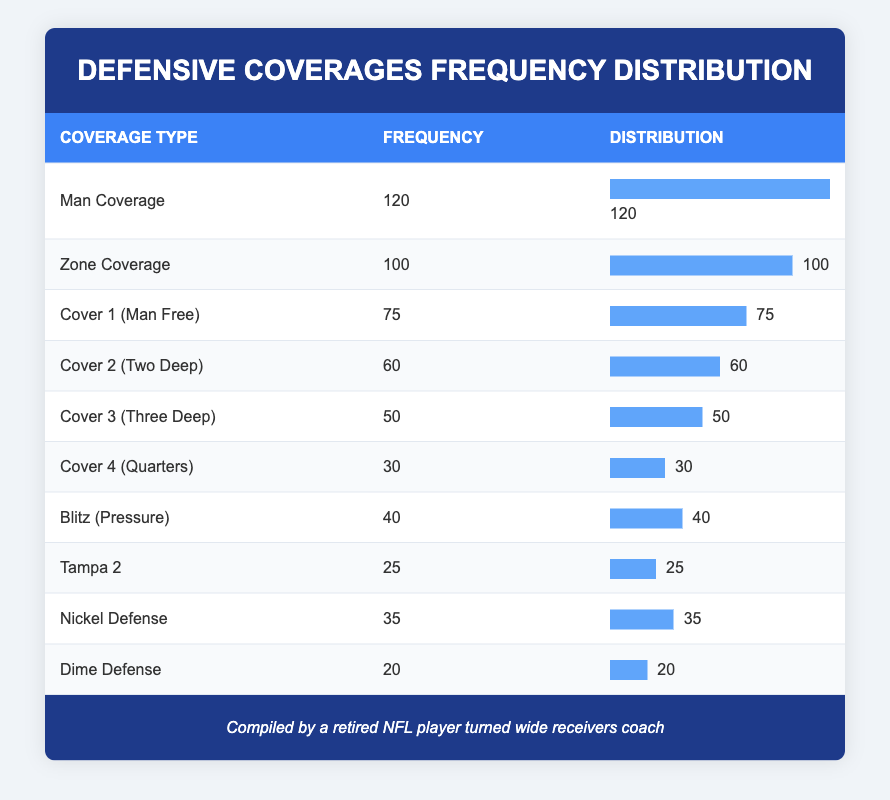What is the frequency of Man Coverage? Man Coverage has a frequency of 120 as stated in the table under the Frequency column.
Answer: 120 What defensive coverage type is faced the least by wide receivers? By looking at the Frequency column, Dime Defense has the lowest frequency at 20.
Answer: Dime Defense What is the total frequency of all defensive coverages combined? Adding up all the frequencies: 120 + 100 + 75 + 60 + 50 + 30 + 40 + 25 + 35 + 20 = 530.
Answer: 530 Is the frequency of Zone Coverage greater than that of Blitz (Pressure)? The frequency for Zone Coverage is 100 and for Blitz (Pressure) is 40. Since 100 is greater than 40, the statement is true.
Answer: Yes What is the average frequency of the top three defensive coverages? The top three defensive coverages by frequency are Man Coverage (120), Zone Coverage (100), and Cover 1 (75). The average is calculated as (120 + 100 + 75) / 3 = 295 / 3 = 98.33.
Answer: 98.33 Which coverage type has a frequency greater than 30 but less than 80? From the Frequency column, the coverage types with frequencies that fall between 30 and 80 are Nickel Defense (35) and Cover 1 (Man Free) (75).
Answer: Nickel Defense and Cover 1 (Man Free) How many more instances of Zone Coverage are there compared to Cover 4 (Quarters)? The frequency for Zone Coverage is 100 and for Cover 4 (Quarters) is 30. The difference is 100 - 30 = 70.
Answer: 70 Is there a coverage type with a frequency less than 50? Cover 4 (Quarters) is at 30, which is less than 50.
Answer: Yes 